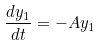<formula> <loc_0><loc_0><loc_500><loc_500>\frac { d y _ { 1 } } { d t } = - A y _ { 1 }</formula> 